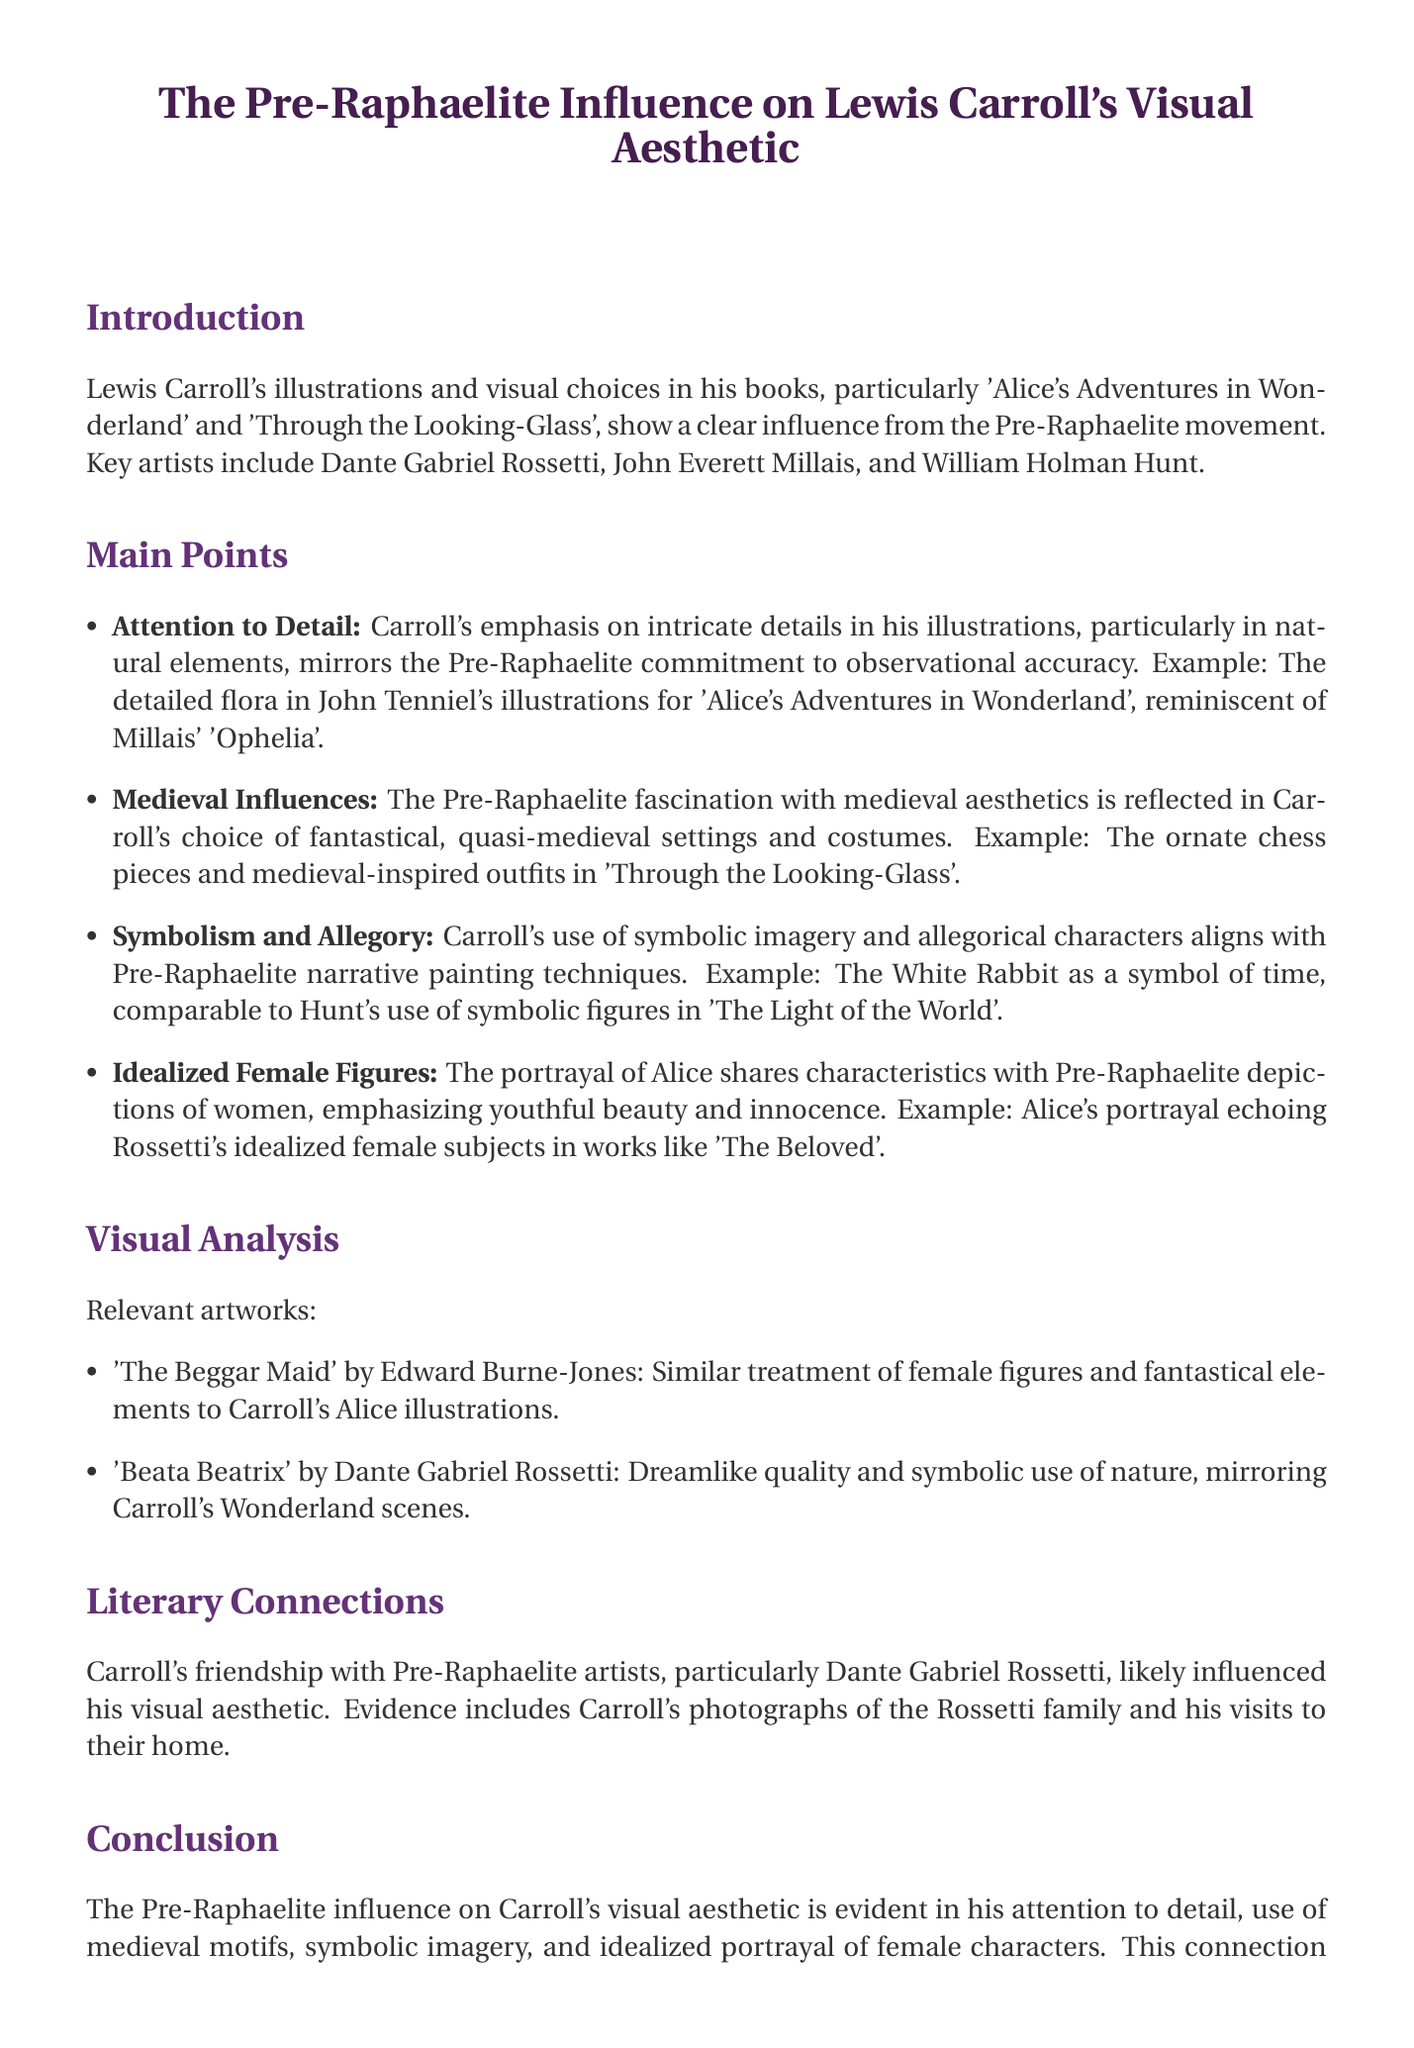What are the key artists associated with Pre-Raphaelite influence? The document lists the key artists as Dante Gabriel Rossetti, John Everett Millais, and William Holman Hunt.
Answer: Dante Gabriel Rossetti, John Everett Millais, William Holman Hunt What is one example of Carroll's attention to detail? The document mentions detailed flora in John Tenniel's illustrations for 'Alice's Adventures in Wonderland', reminiscent of Millais' 'Ophelia'.
Answer: Detailed flora in John Tenniel's illustrations What motifs are reflected in Carroll's work due to medieval influences? The document states that Carroll chose fantastical, quasi-medieval settings and costumes, such as ornate chess pieces and medieval-inspired outfits in 'Through the Looking-Glass'.
Answer: Ornate chess pieces, medieval-inspired outfits What symbolic figure does Carroll use to represent time? The document identifies the White Rabbit as a symbol of time, comparable to Hunt's use of symbolic figures in 'The Light of the World'.
Answer: The White Rabbit Which artwork by Edward Burne-Jones is relevant to Carroll's illustrations? The document mentions 'The Beggar Maid' as a relevant artwork that shares a similar treatment of female figures and fantastical elements.
Answer: The Beggar Maid What type of aesthetic is highlighted in Carroll's representation of female figures? The document notes that Alice's portrayal shares characteristics with Pre-Raphaelite depictions, emphasizing youthful beauty and innocence.
Answer: Youthful beauty and innocence Who likely influenced Carroll's visual aesthetic? The document indicates that Carroll's friendship with Pre-Raphaelite artists, particularly Dante Gabriel Rossetti, likely influenced his visual aesthetic.
Answer: Dante Gabriel Rossetti How does the document categorize its content? The document organizes its content into sections such as Introduction, Main Points, Visual Analysis, Literary Connections, and Conclusion.
Answer: Into sections such as Introduction, Main Points, Visual Analysis, Literary Connections, and Conclusion 